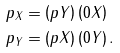<formula> <loc_0><loc_0><loc_500><loc_500>p _ { X } & = \left ( p Y \right ) \left ( 0 X \right ) \\ p _ { Y } & = \left ( p X \right ) \left ( 0 Y \right ) .</formula> 